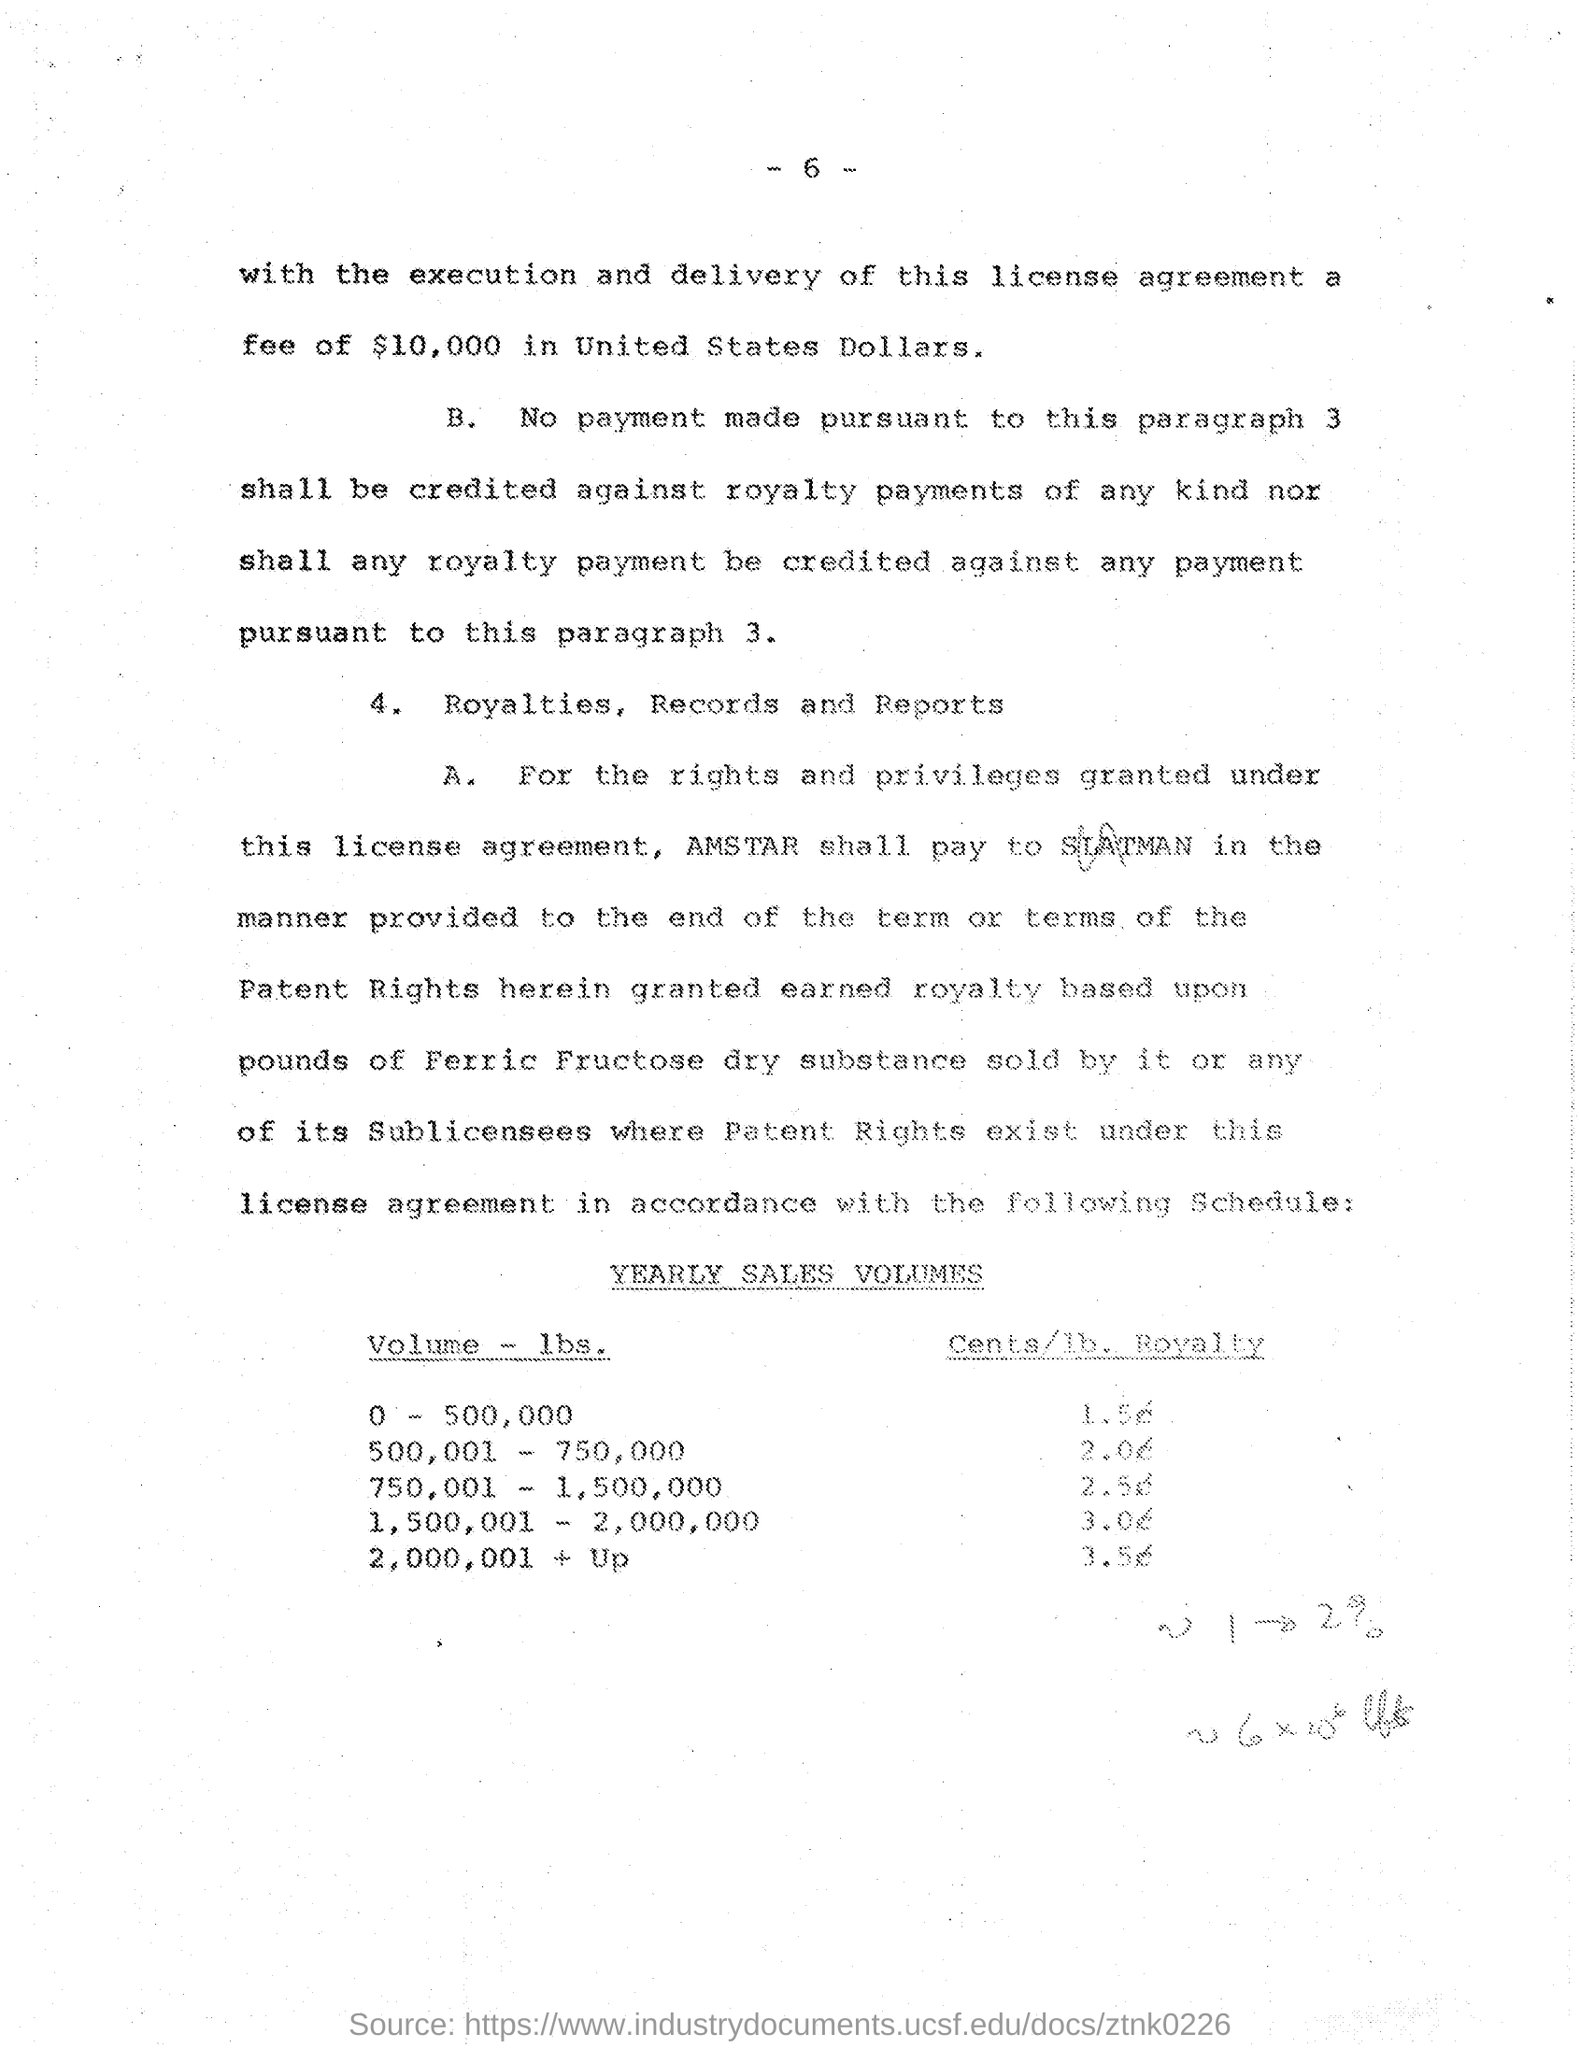What amount is Fee?
Give a very brief answer. $10,000. 